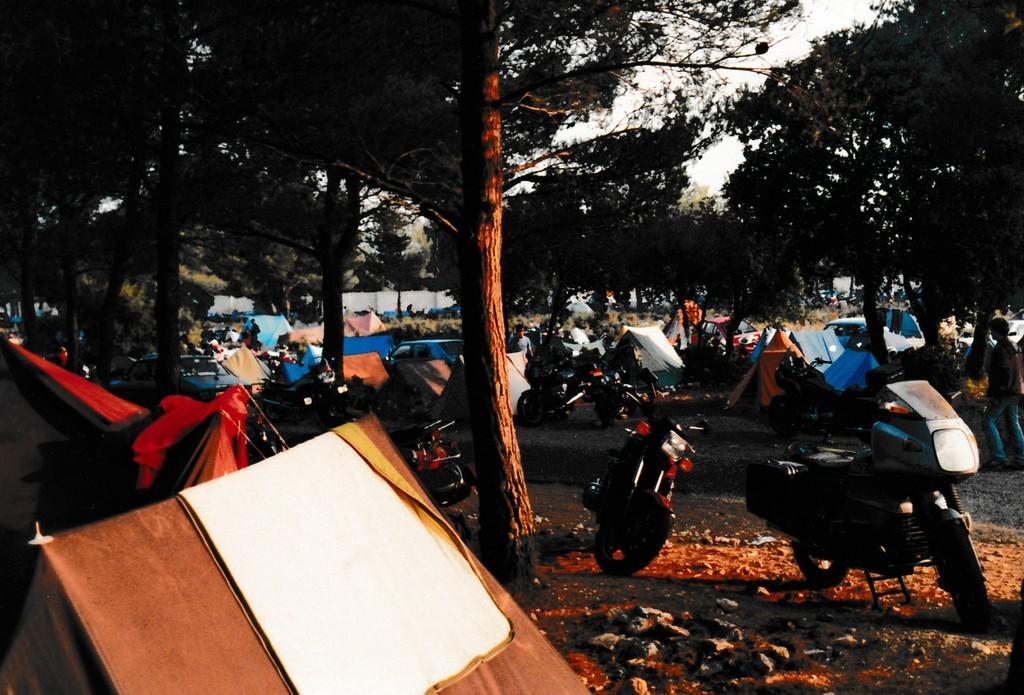How would you summarize this image in a sentence or two? In this picture we can see a few vehicles, stones and tents on the path. There are a few people visible on the path. We can see some trees in the background. 